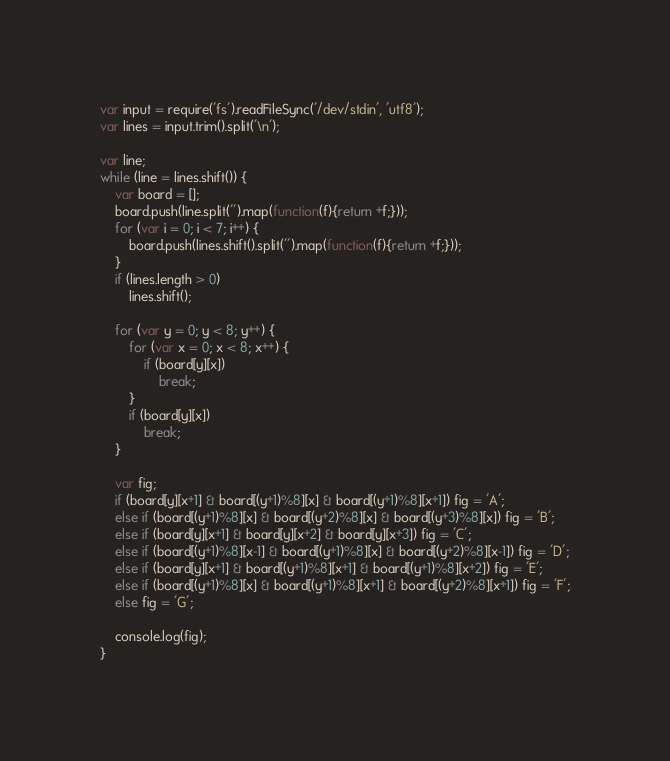Convert code to text. <code><loc_0><loc_0><loc_500><loc_500><_JavaScript_>var input = require('fs').readFileSync('/dev/stdin', 'utf8');
var lines = input.trim().split('\n');

var line;
while (line = lines.shift()) {
	var board = [];
	board.push(line.split('').map(function(f){return +f;}));
	for (var i = 0; i < 7; i++) {
		board.push(lines.shift().split('').map(function(f){return +f;}));
	}
	if (lines.length > 0)
		lines.shift();

	for (var y = 0; y < 8; y++) {
		for (var x = 0; x < 8; x++) {
			if (board[y][x])
				break;
		}
		if (board[y][x])
			break;
	}

	var fig;
	if (board[y][x+1] & board[(y+1)%8][x] & board[(y+1)%8][x+1]) fig = 'A';
	else if (board[(y+1)%8][x] & board[(y+2)%8][x] & board[(y+3)%8][x]) fig = 'B';
	else if (board[y][x+1] & board[y][x+2] & board[y][x+3]) fig = 'C';
	else if (board[(y+1)%8][x-1] & board[(y+1)%8][x] & board[(y+2)%8][x-1]) fig = 'D';
	else if (board[y][x+1] & board[(y+1)%8][x+1] & board[(y+1)%8][x+2]) fig = 'E';
	else if (board[(y+1)%8][x] & board[(y+1)%8][x+1] & board[(y+2)%8][x+1]) fig = 'F';
	else fig = 'G';

	console.log(fig);
}</code> 